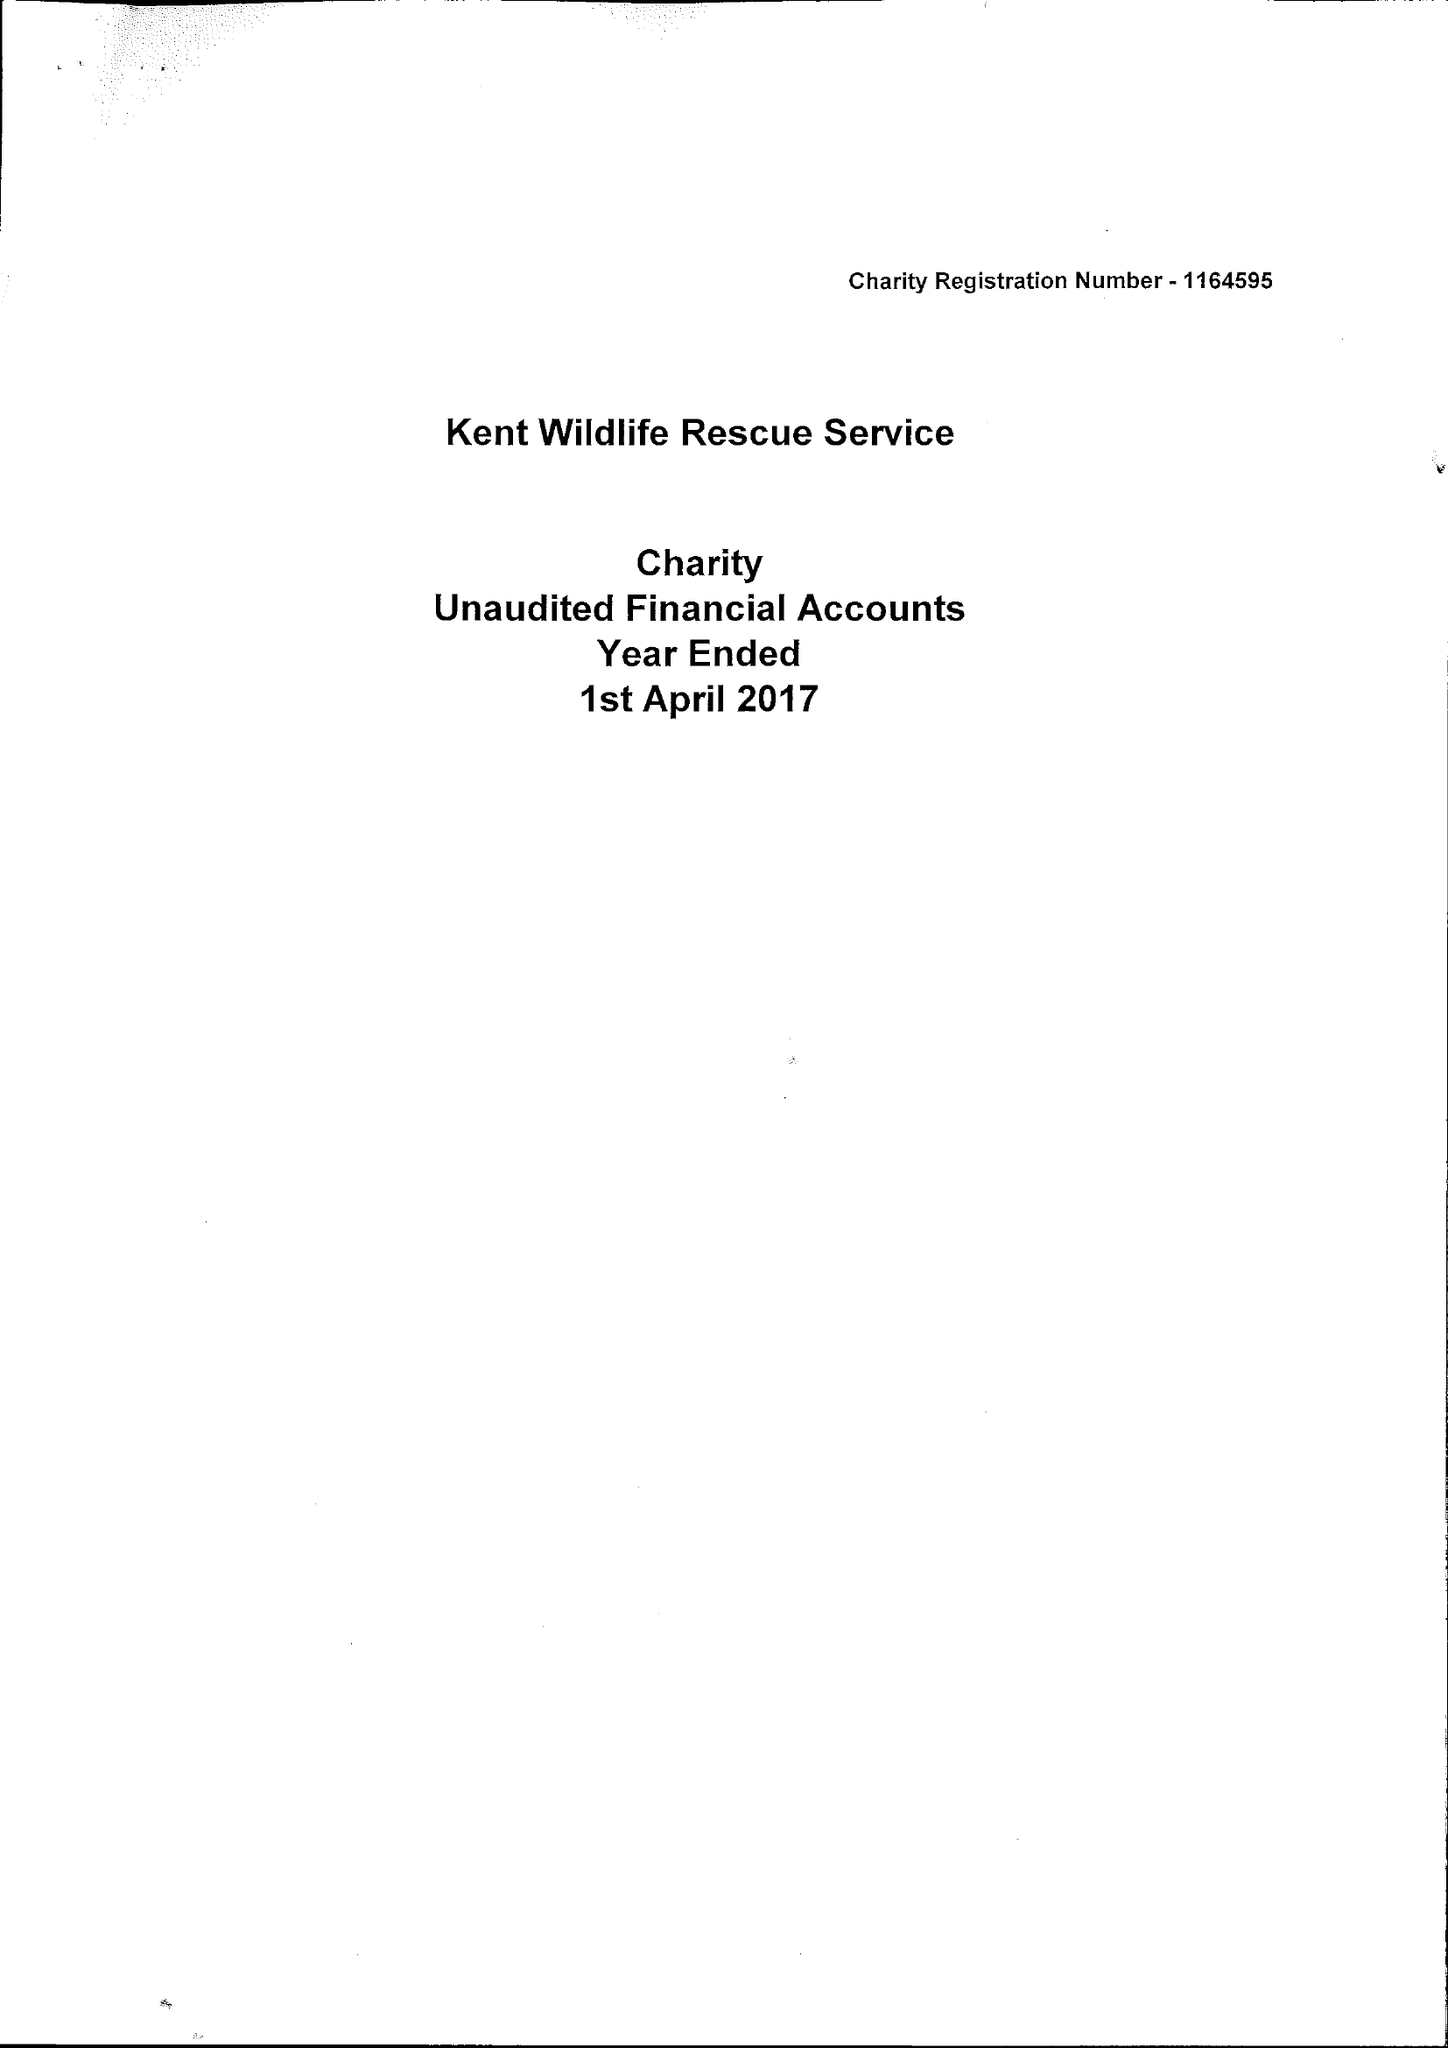What is the value for the report_date?
Answer the question using a single word or phrase. 2017-04-01 